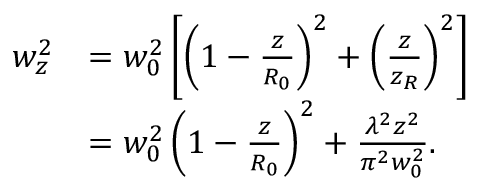<formula> <loc_0><loc_0><loc_500><loc_500>\begin{array} { r l } { w _ { z } ^ { 2 } } & { = w _ { 0 } ^ { 2 } \left [ \left ( 1 - \frac { z } { R _ { 0 } } \right ) ^ { 2 } + \left ( \frac { z } { z _ { R } } \right ) ^ { 2 } \right ] } \\ & { = w _ { 0 } ^ { 2 } \left ( 1 - \frac { z } { R _ { 0 } } \right ) ^ { 2 } + \frac { \lambda ^ { 2 } z ^ { 2 } } { \pi ^ { 2 } w _ { 0 } ^ { 2 } } . } \end{array}</formula> 